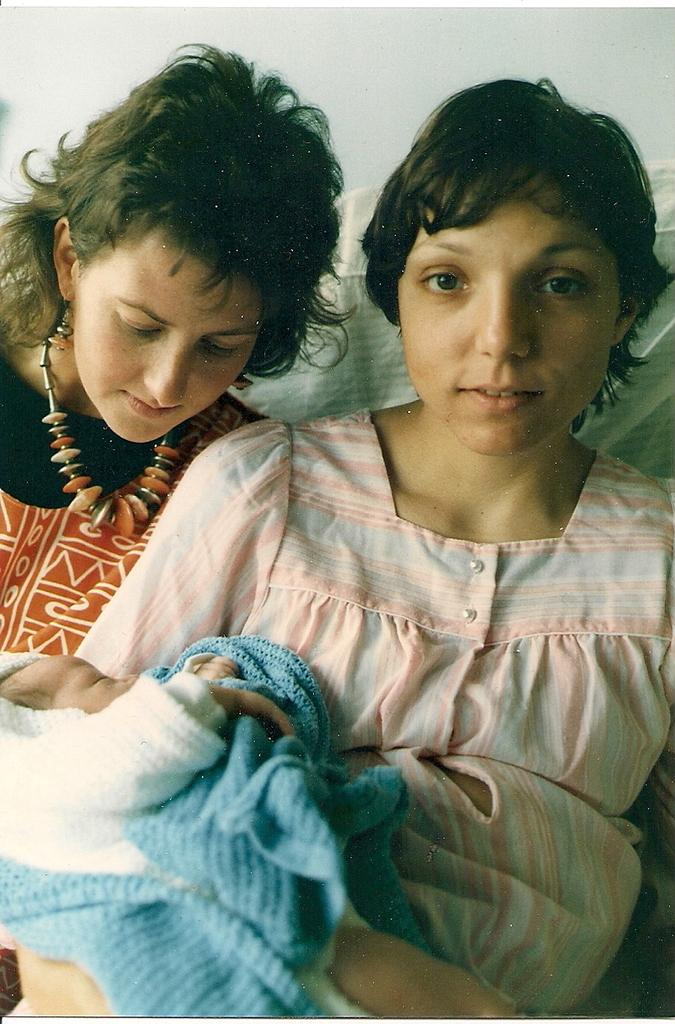How many people are present in the image? There are two people in the image. What is the woman carrying in the image? One woman is carrying a baby. What is the other woman doing in the image? The other woman is looking at the baby. What type of beef can be seen in the image? There is no beef present in the image. Is it raining in the image? The provided facts do not mention any weather conditions, so we cannot determine if it is raining in the image. 